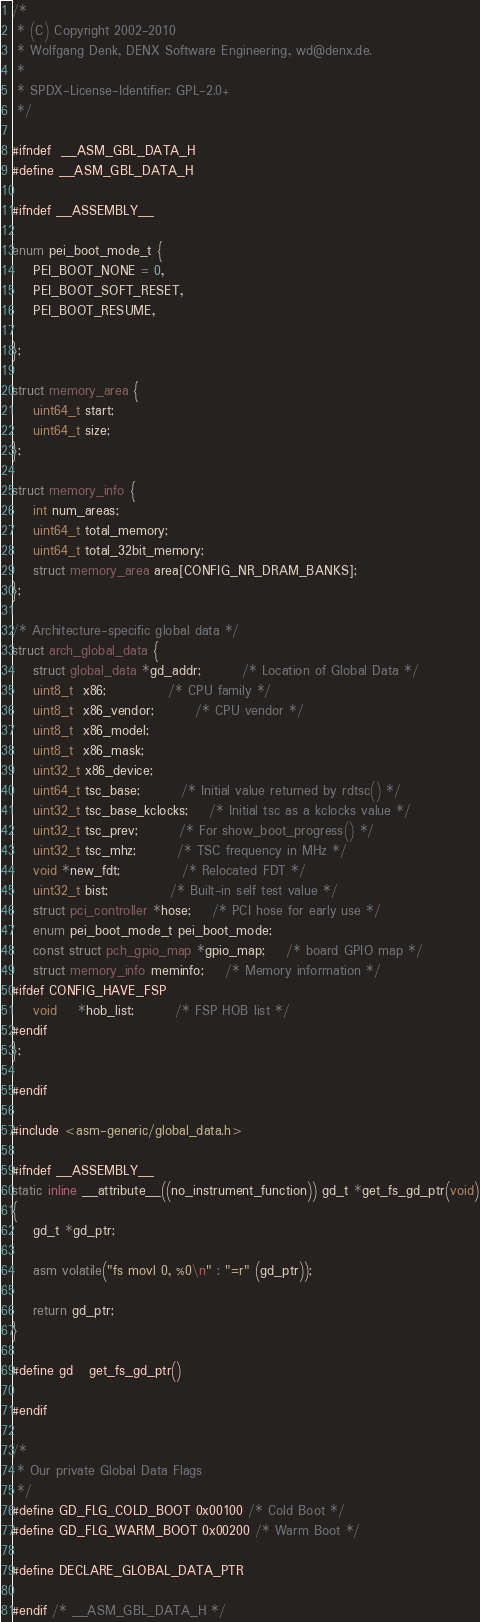Convert code to text. <code><loc_0><loc_0><loc_500><loc_500><_C_>/*
 * (C) Copyright 2002-2010
 * Wolfgang Denk, DENX Software Engineering, wd@denx.de.
 *
 * SPDX-License-Identifier:	GPL-2.0+
 */

#ifndef	__ASM_GBL_DATA_H
#define __ASM_GBL_DATA_H

#ifndef __ASSEMBLY__

enum pei_boot_mode_t {
	PEI_BOOT_NONE = 0,
	PEI_BOOT_SOFT_RESET,
	PEI_BOOT_RESUME,

};

struct memory_area {
	uint64_t start;
	uint64_t size;
};

struct memory_info {
	int num_areas;
	uint64_t total_memory;
	uint64_t total_32bit_memory;
	struct memory_area area[CONFIG_NR_DRAM_BANKS];
};

/* Architecture-specific global data */
struct arch_global_data {
	struct global_data *gd_addr;		/* Location of Global Data */
	uint8_t  x86;			/* CPU family */
	uint8_t  x86_vendor;		/* CPU vendor */
	uint8_t  x86_model;
	uint8_t  x86_mask;
	uint32_t x86_device;
	uint64_t tsc_base;		/* Initial value returned by rdtsc() */
	uint32_t tsc_base_kclocks;	/* Initial tsc as a kclocks value */
	uint32_t tsc_prev;		/* For show_boot_progress() */
	uint32_t tsc_mhz;		/* TSC frequency in MHz */
	void *new_fdt;			/* Relocated FDT */
	uint32_t bist;			/* Built-in self test value */
	struct pci_controller *hose;	/* PCI hose for early use */
	enum pei_boot_mode_t pei_boot_mode;
	const struct pch_gpio_map *gpio_map;	/* board GPIO map */
	struct memory_info meminfo;	/* Memory information */
#ifdef CONFIG_HAVE_FSP
	void	*hob_list;		/* FSP HOB list */
#endif
};

#endif

#include <asm-generic/global_data.h>

#ifndef __ASSEMBLY__
static inline __attribute__((no_instrument_function)) gd_t *get_fs_gd_ptr(void)
{
	gd_t *gd_ptr;

	asm volatile("fs movl 0, %0\n" : "=r" (gd_ptr));

	return gd_ptr;
}

#define gd	get_fs_gd_ptr()

#endif

/*
 * Our private Global Data Flags
 */
#define GD_FLG_COLD_BOOT	0x00100	/* Cold Boot */
#define GD_FLG_WARM_BOOT	0x00200	/* Warm Boot */

#define DECLARE_GLOBAL_DATA_PTR

#endif /* __ASM_GBL_DATA_H */
</code> 